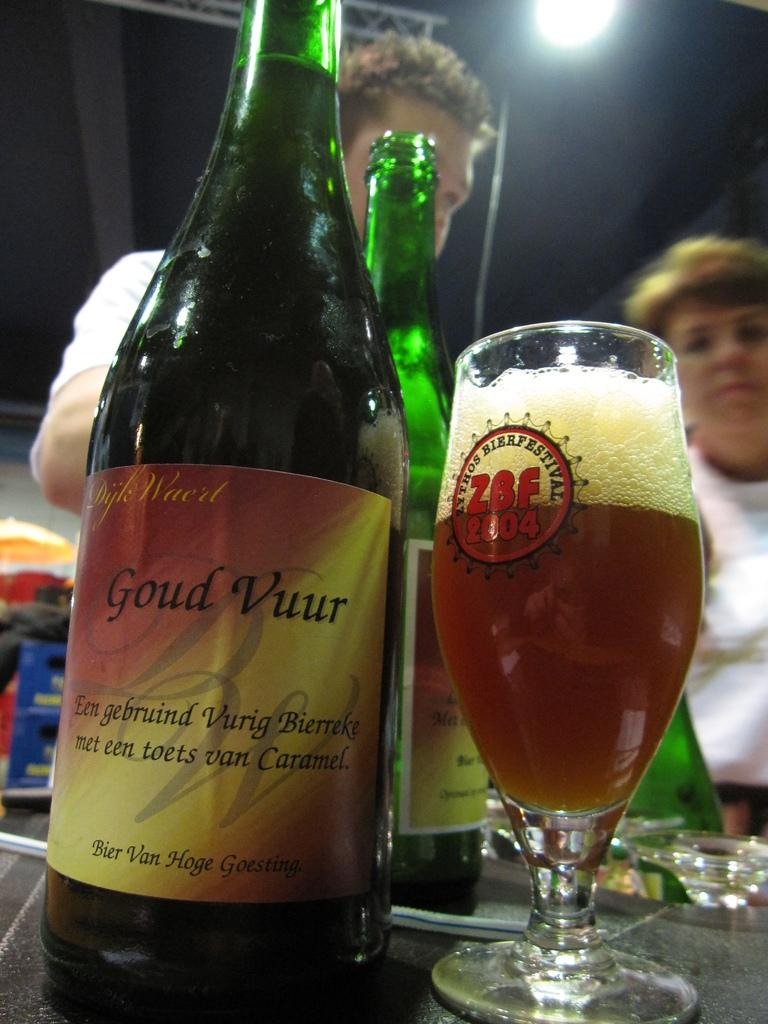<image>
Relay a brief, clear account of the picture shown. A glass of beer is from a 2004 festival. 